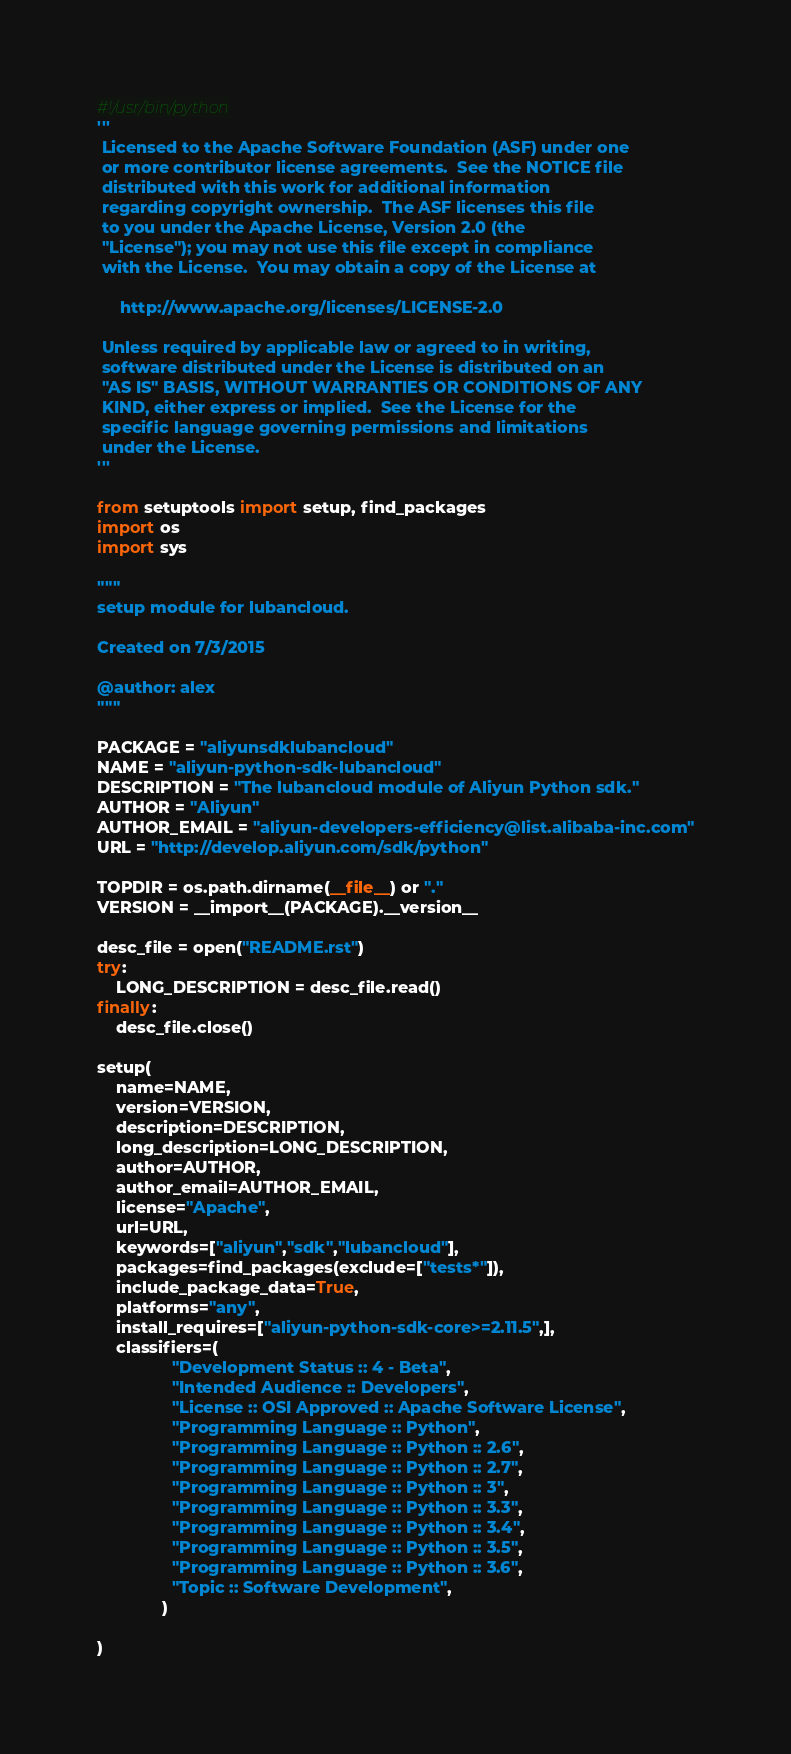Convert code to text. <code><loc_0><loc_0><loc_500><loc_500><_Python_>#!/usr/bin/python
'''
 Licensed to the Apache Software Foundation (ASF) under one
 or more contributor license agreements.  See the NOTICE file
 distributed with this work for additional information
 regarding copyright ownership.  The ASF licenses this file
 to you under the Apache License, Version 2.0 (the
 "License"); you may not use this file except in compliance
 with the License.  You may obtain a copy of the License at

     http://www.apache.org/licenses/LICENSE-2.0

 Unless required by applicable law or agreed to in writing,
 software distributed under the License is distributed on an
 "AS IS" BASIS, WITHOUT WARRANTIES OR CONDITIONS OF ANY
 KIND, either express or implied.  See the License for the
 specific language governing permissions and limitations
 under the License.
'''

from setuptools import setup, find_packages
import os
import sys

"""
setup module for lubancloud.

Created on 7/3/2015

@author: alex
"""

PACKAGE = "aliyunsdklubancloud"
NAME = "aliyun-python-sdk-lubancloud"
DESCRIPTION = "The lubancloud module of Aliyun Python sdk."
AUTHOR = "Aliyun"
AUTHOR_EMAIL = "aliyun-developers-efficiency@list.alibaba-inc.com"
URL = "http://develop.aliyun.com/sdk/python"

TOPDIR = os.path.dirname(__file__) or "."
VERSION = __import__(PACKAGE).__version__

desc_file = open("README.rst")
try:
	LONG_DESCRIPTION = desc_file.read()
finally:
	desc_file.close()

setup(
    name=NAME,
    version=VERSION,
    description=DESCRIPTION,
    long_description=LONG_DESCRIPTION,
    author=AUTHOR,
    author_email=AUTHOR_EMAIL,
    license="Apache",
    url=URL,
    keywords=["aliyun","sdk","lubancloud"],
    packages=find_packages(exclude=["tests*"]),
    include_package_data=True,
    platforms="any",
    install_requires=["aliyun-python-sdk-core>=2.11.5",],
    classifiers=(
                "Development Status :: 4 - Beta",
                "Intended Audience :: Developers",
                "License :: OSI Approved :: Apache Software License",
                "Programming Language :: Python",
                "Programming Language :: Python :: 2.6",
                "Programming Language :: Python :: 2.7",
                "Programming Language :: Python :: 3",
                "Programming Language :: Python :: 3.3",
                "Programming Language :: Python :: 3.4",
                "Programming Language :: Python :: 3.5",
                "Programming Language :: Python :: 3.6",
                "Topic :: Software Development",
              )

)</code> 